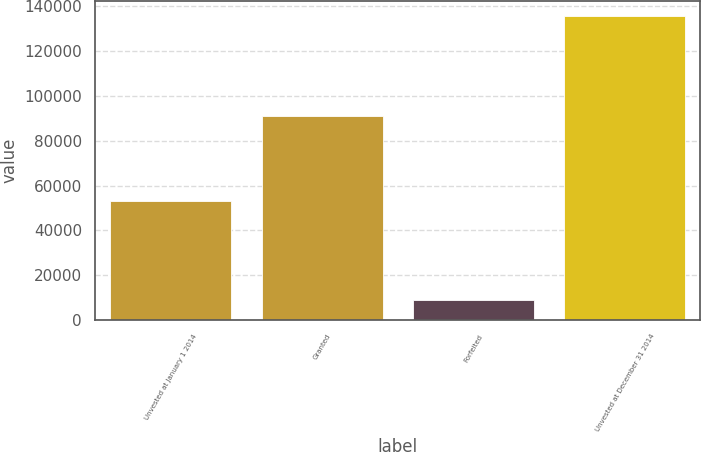Convert chart. <chart><loc_0><loc_0><loc_500><loc_500><bar_chart><fcel>Unvested at January 1 2014<fcel>Granted<fcel>Forfeited<fcel>Unvested at December 31 2014<nl><fcel>53205<fcel>91030<fcel>8695<fcel>135540<nl></chart> 